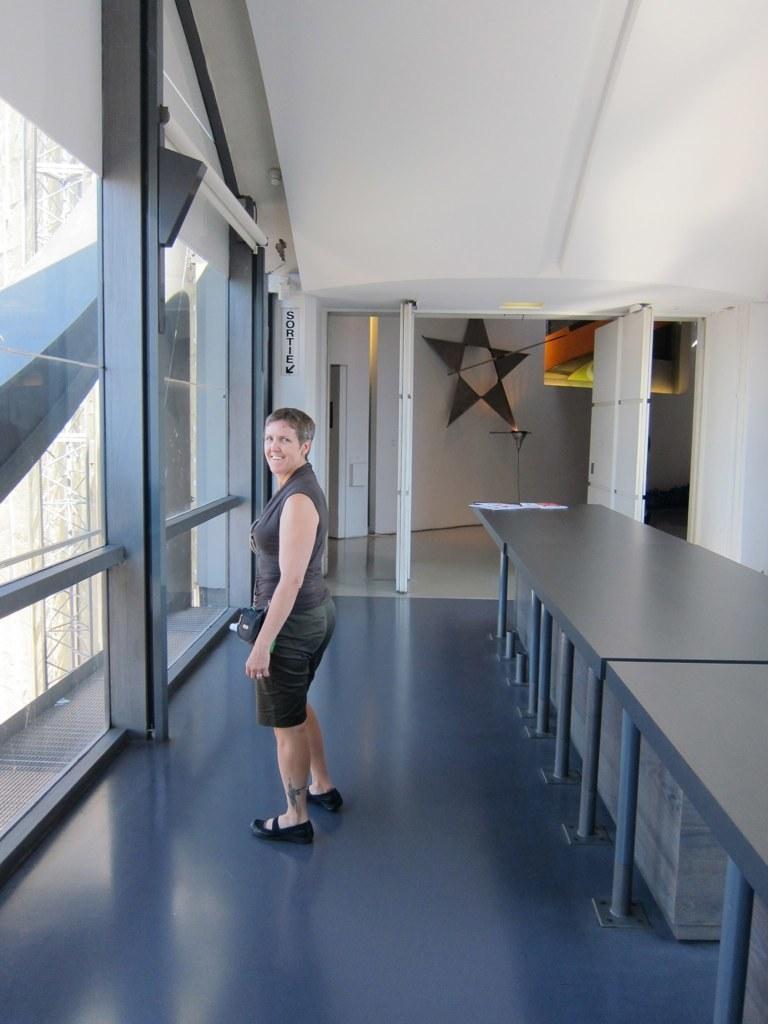How would you summarize this image in a sentence or two? In this image I can see the person standing and wearing the dress. In-front of the person I can see the glass. Through the glass I can see the tower. To the right I can see the tables. In the background I can see the star to the wall. 